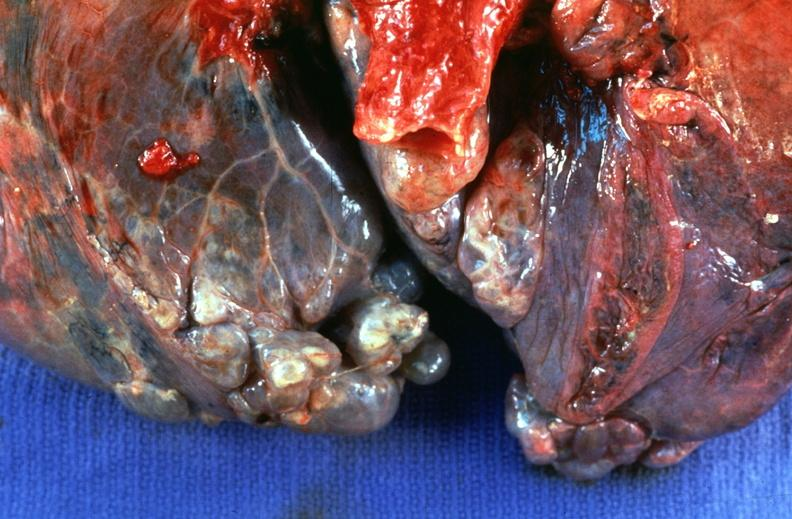what is present?
Answer the question using a single word or phrase. Respiratory 